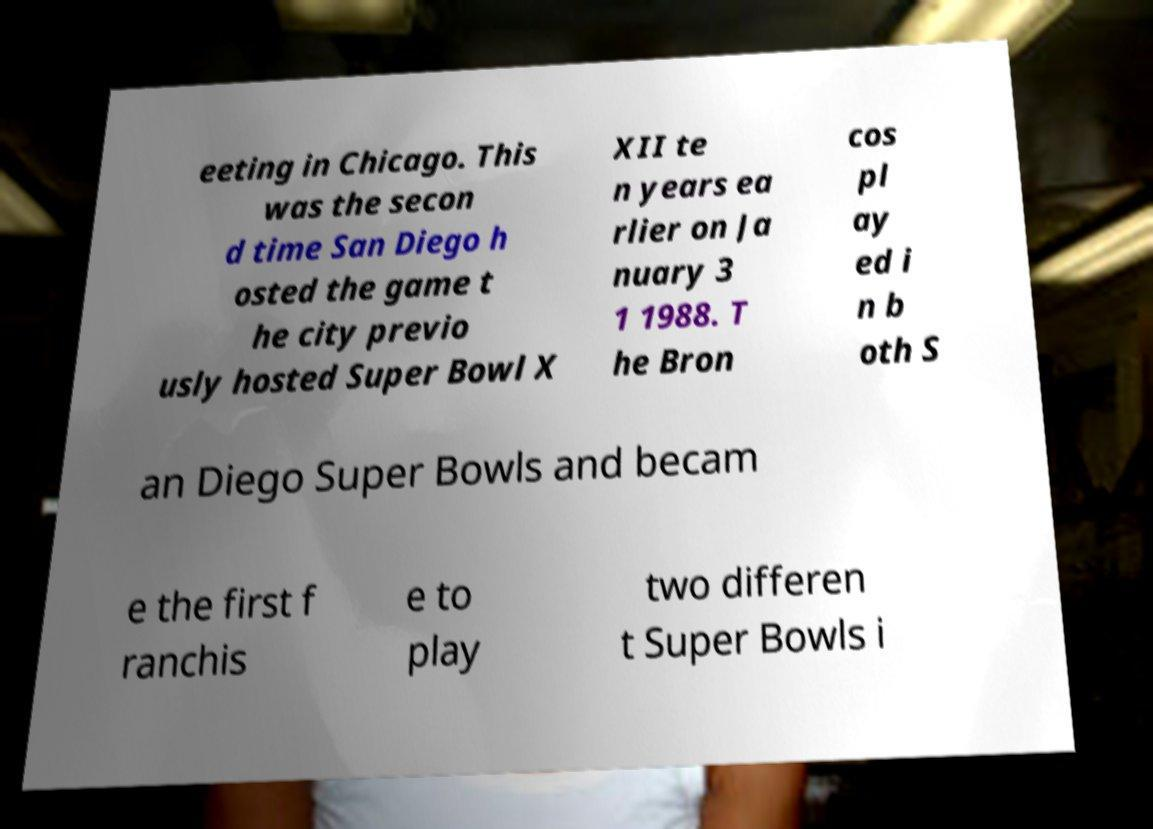Could you assist in decoding the text presented in this image and type it out clearly? eeting in Chicago. This was the secon d time San Diego h osted the game t he city previo usly hosted Super Bowl X XII te n years ea rlier on Ja nuary 3 1 1988. T he Bron cos pl ay ed i n b oth S an Diego Super Bowls and becam e the first f ranchis e to play two differen t Super Bowls i 